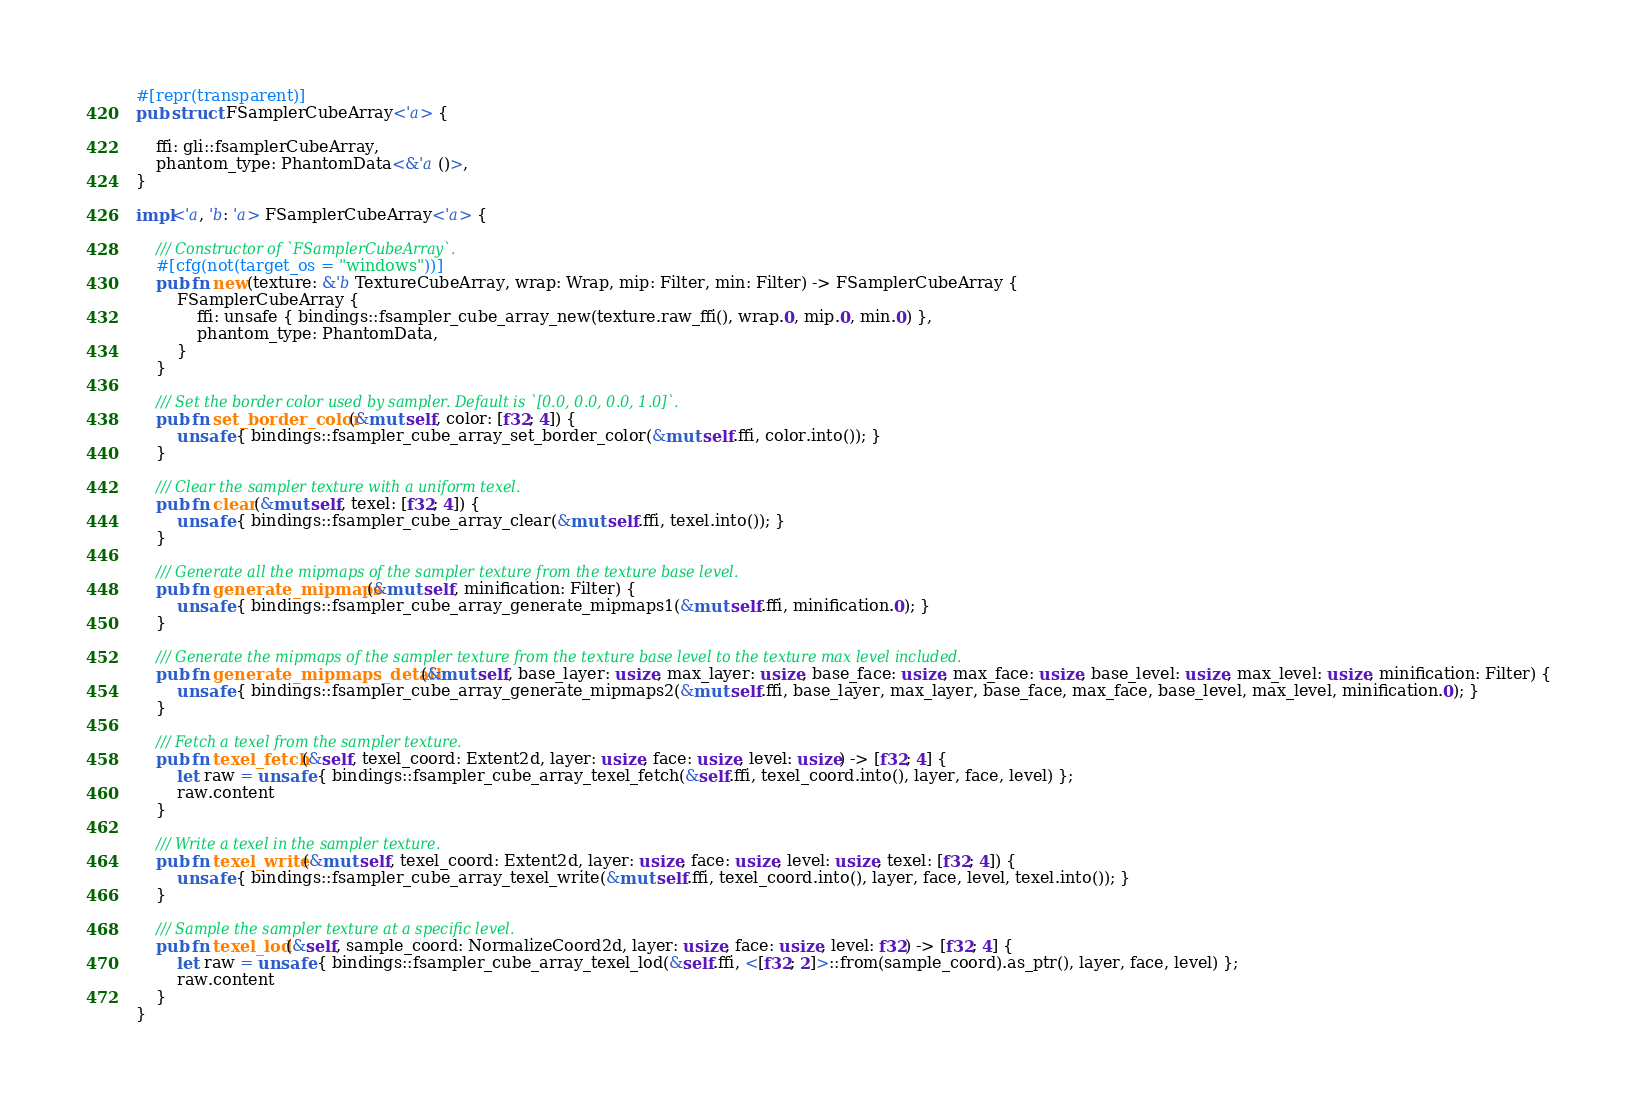Convert code to text. <code><loc_0><loc_0><loc_500><loc_500><_Rust_>#[repr(transparent)]
pub struct FSamplerCubeArray<'a> {

    ffi: gli::fsamplerCubeArray,
    phantom_type: PhantomData<&'a ()>,
}

impl<'a, 'b: 'a> FSamplerCubeArray<'a> {

    /// Constructor of `FSamplerCubeArray`.
    #[cfg(not(target_os = "windows"))]
    pub fn new(texture: &'b TextureCubeArray, wrap: Wrap, mip: Filter, min: Filter) -> FSamplerCubeArray {
        FSamplerCubeArray {
            ffi: unsafe { bindings::fsampler_cube_array_new(texture.raw_ffi(), wrap.0, mip.0, min.0) },
            phantom_type: PhantomData,
        }
    }

    /// Set the border color used by sampler. Default is `[0.0, 0.0, 0.0, 1.0]`.
    pub fn set_border_color(&mut self, color: [f32; 4]) {
        unsafe { bindings::fsampler_cube_array_set_border_color(&mut self.ffi, color.into()); }
    }

    /// Clear the sampler texture with a uniform texel.
    pub fn clear(&mut self, texel: [f32; 4]) {
        unsafe { bindings::fsampler_cube_array_clear(&mut self.ffi, texel.into()); }
    }

    /// Generate all the mipmaps of the sampler texture from the texture base level.
    pub fn generate_mipmaps(&mut self, minification: Filter) {
        unsafe { bindings::fsampler_cube_array_generate_mipmaps1(&mut self.ffi, minification.0); }
    }

    /// Generate the mipmaps of the sampler texture from the texture base level to the texture max level included.
    pub fn generate_mipmaps_detail(&mut self, base_layer: usize, max_layer: usize, base_face: usize, max_face: usize, base_level: usize, max_level: usize, minification: Filter) {
        unsafe { bindings::fsampler_cube_array_generate_mipmaps2(&mut self.ffi, base_layer, max_layer, base_face, max_face, base_level, max_level, minification.0); }
    }

    /// Fetch a texel from the sampler texture.
    pub fn texel_fetch(&self, texel_coord: Extent2d, layer: usize, face: usize, level: usize) -> [f32; 4] {
        let raw = unsafe { bindings::fsampler_cube_array_texel_fetch(&self.ffi, texel_coord.into(), layer, face, level) };
        raw.content
    }

    /// Write a texel in the sampler texture.
    pub fn texel_write(&mut self, texel_coord: Extent2d, layer: usize, face: usize, level: usize, texel: [f32; 4]) {
        unsafe { bindings::fsampler_cube_array_texel_write(&mut self.ffi, texel_coord.into(), layer, face, level, texel.into()); }
    }

    /// Sample the sampler texture at a specific level.
    pub fn texel_lod(&self, sample_coord: NormalizeCoord2d, layer: usize, face: usize, level: f32) -> [f32; 4] {
        let raw = unsafe { bindings::fsampler_cube_array_texel_lod(&self.ffi, <[f32; 2]>::from(sample_coord).as_ptr(), layer, face, level) };
        raw.content
    }
}
</code> 